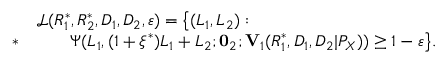Convert formula to latex. <formula><loc_0><loc_0><loc_500><loc_500>\begin{array} { r l } & { \mathcal { L } ( R _ { 1 } ^ { * } , R _ { 2 } ^ { * } , D _ { 1 } , D _ { 2 } , \varepsilon ) = \left \{ ( L _ { 1 } , L _ { 2 } ) \colon } \\ { * } & { \quad \Psi ( L _ { 1 } , ( 1 + \xi ^ { * } ) L _ { 1 } + L _ { 2 } ; 0 _ { 2 } ; V _ { 1 } ( R _ { 1 } ^ { * } , D _ { 1 } , D _ { 2 } | P _ { X } ) ) \geq 1 - \varepsilon \right \} . } \end{array}</formula> 